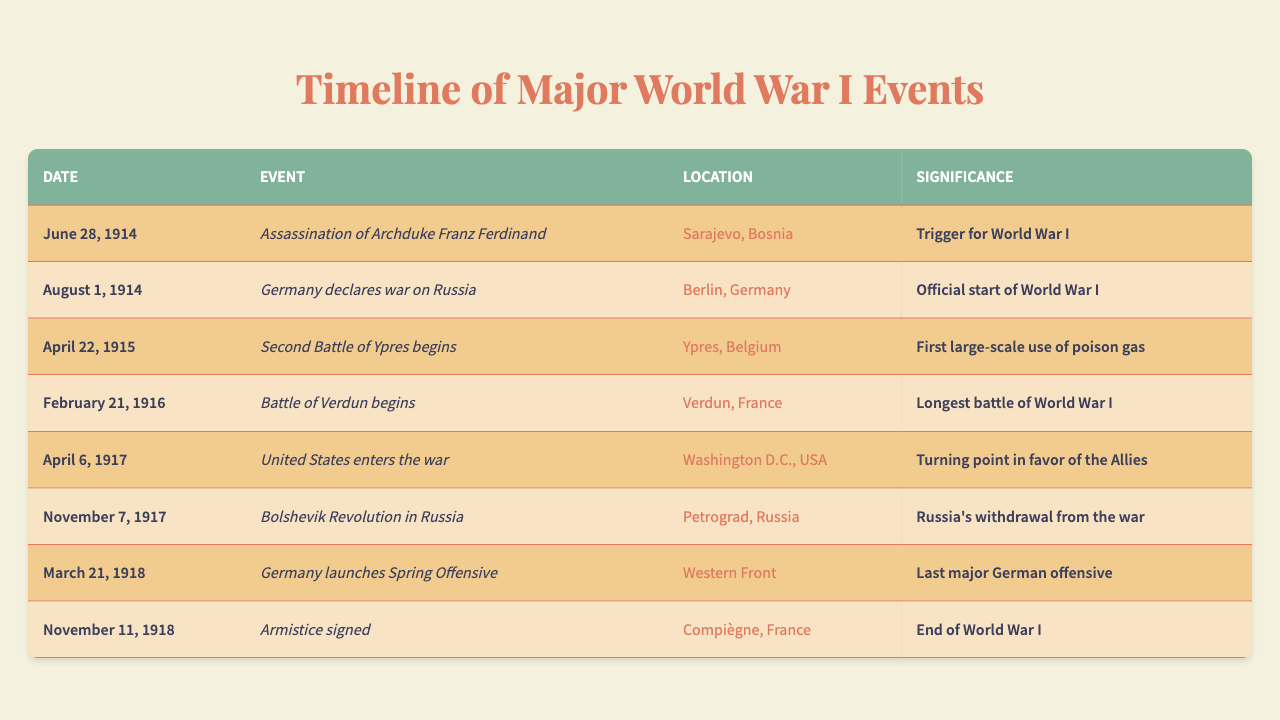What event is considered the trigger for World War I? By looking at the table, the event listed on "June 28, 1914" is "Assassination of Archduke Franz Ferdinand," and it is labeled as the trigger for World War I.
Answer: Assassination of Archduke Franz Ferdinand When did the United States enter the war? The table shows that the United States entered the war on "April 6, 1917."
Answer: April 6, 1917 What was the significance of the Second Battle of Ypres? The table indicates that the Second Battle of Ypres began on "April 22, 1915," and its significance is noted as the first large-scale use of poison gas.
Answer: First large-scale use of poison gas Was the Battle of Verdun the longest battle of World War I? According to the table, the Battle of Verdun began on "February 21, 1916," and it states that this battle was the longest battle of World War I, making the statement true.
Answer: Yes How many major events listed occurred before the United States entered the war? The events that occurred before April 6, 1917, are: "Assassination of Archduke Franz Ferdinand," "Germany declares war on Russia," "Second Battle of Ypres begins," "Battle of Verdun begins," and "Bolshevik Revolution in Russia." This totals to 5 events.
Answer: 5 What location was involved in the signing of the Armistice? The table shows that the armistice was signed at "Compiègne, France" on "November 11, 1918."
Answer: Compiègne, France Is there a significant correlation between the dates of major events and their location in Europe? Each listed event occurs in countries in Europe, except for the United States' entry into the war. Notably, many significant events such as battles and declarations occurred in France, Germany, and Belgium, indicating a strong geographic concentration in Europe.
Answer: Yes What is the event that marked Russia's withdrawal from the war? The table indicates the "Bolshevik Revolution in Russia" on "November 7, 1917" as the event that marked Russia's withdrawal from the war.
Answer: Bolshevik Revolution in Russia Which event occurred last in the timeline and what was its significance? The event that occurred last is the "Armistice signed" on "November 11, 1918," which is significant as it marks the end of World War I.
Answer: Armistice signed; end of World War I Did Germany launch its Spring Offensive before or after the United States entered the war? The Spring Offensive was launched on "March 21, 1918," which is after the United States entered the war on "April 6, 1917." Thus, the Spring Offensive occurred after the U.S. entry.
Answer: After 